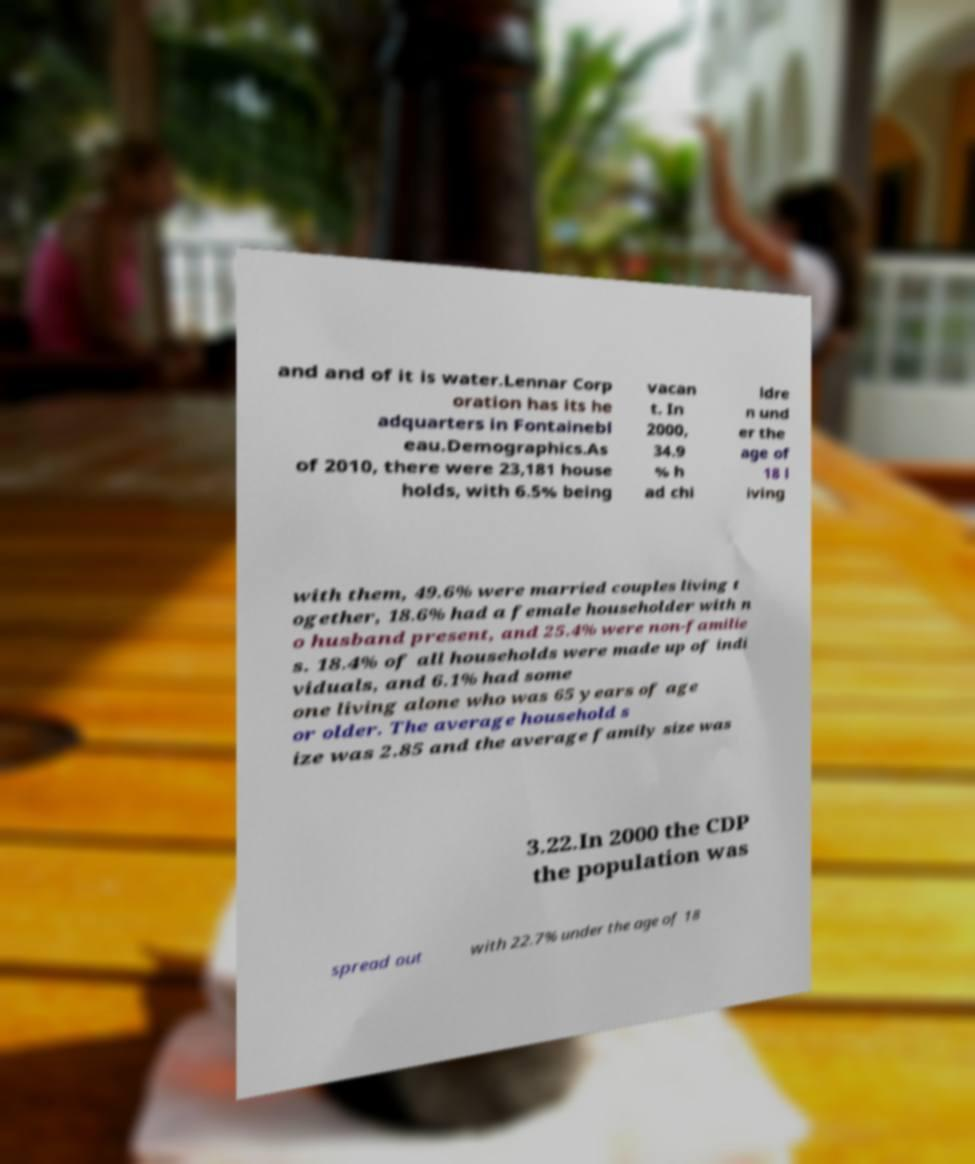Can you read and provide the text displayed in the image?This photo seems to have some interesting text. Can you extract and type it out for me? and and of it is water.Lennar Corp oration has its he adquarters in Fontainebl eau.Demographics.As of 2010, there were 23,181 house holds, with 6.5% being vacan t. In 2000, 34.9 % h ad chi ldre n und er the age of 18 l iving with them, 49.6% were married couples living t ogether, 18.6% had a female householder with n o husband present, and 25.4% were non-familie s. 18.4% of all households were made up of indi viduals, and 6.1% had some one living alone who was 65 years of age or older. The average household s ize was 2.85 and the average family size was 3.22.In 2000 the CDP the population was spread out with 22.7% under the age of 18 